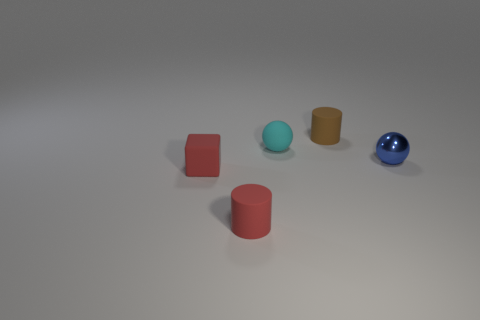Add 3 balls. How many objects exist? 8 Subtract all cylinders. How many objects are left? 3 Subtract all big brown matte cylinders. Subtract all brown cylinders. How many objects are left? 4 Add 4 red cubes. How many red cubes are left? 5 Add 4 tiny blue metallic spheres. How many tiny blue metallic spheres exist? 5 Subtract 0 yellow blocks. How many objects are left? 5 